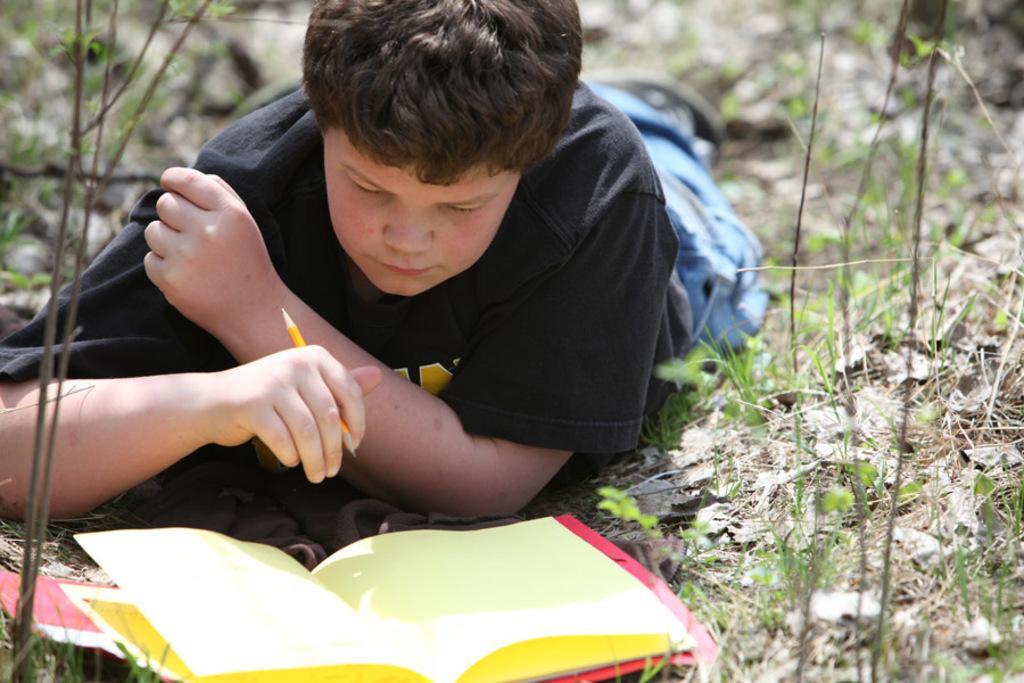Describe this image in one or two sentences. In this image there is one person lying on the ground and holding a pen in middle of this image and there is a book at bottom of this image. There are some small plants at right side of this image and left side of this image as well. 